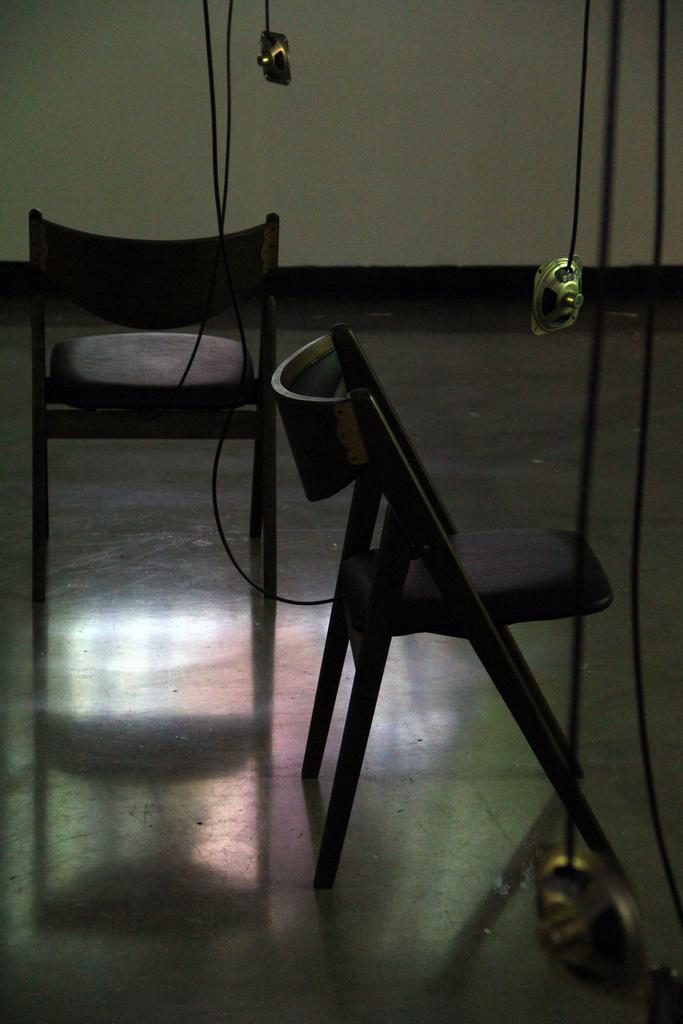How many chairs are in the image? There are two chairs in the image. Where are the chairs located? The chairs are placed on the ground. What can be seen in the background of the image? There are speakers visible in the background of the image. What is connected to the speakers? Cables are associated with the speakers. Can you see any apples on the chairs in the image? There are no apples present on the chairs or in the image. 